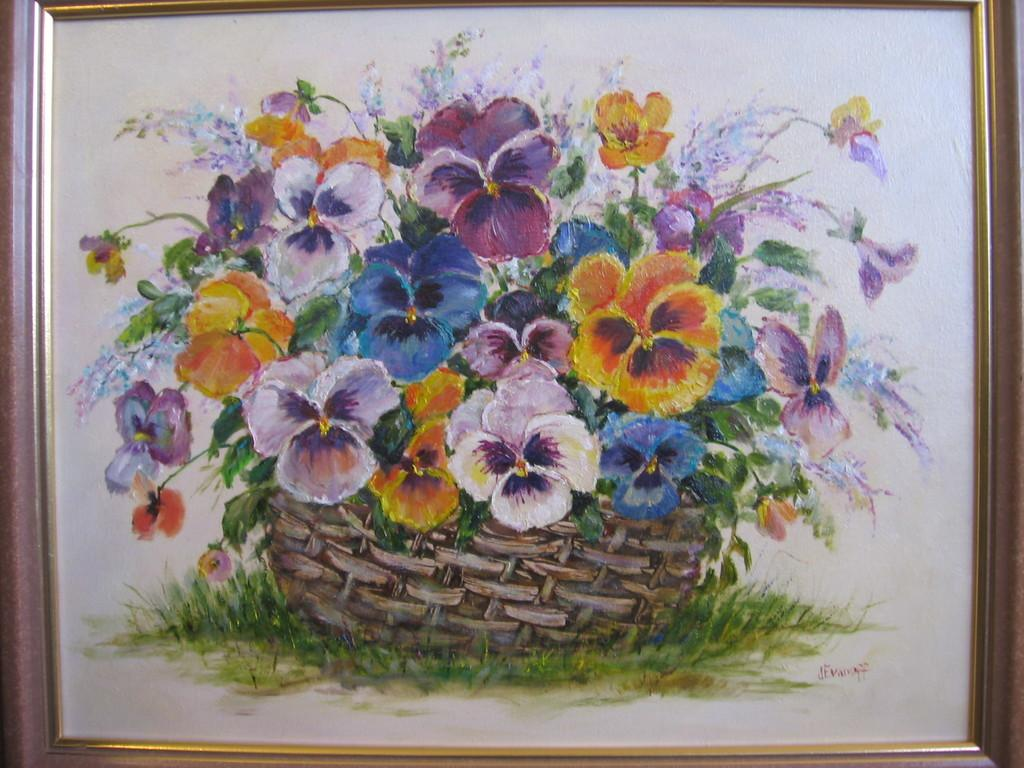What is the main subject of the image? The image contains a frame with a painting. What type of natural elements can be seen in the image? There are flowers and grass in the image. Can you describe any other objects present in the image? Yes, there are other objects in the image. What color is the background of the image? The background of the image is white. What type of fan is visible in the image? There is no fan present in the image. Can you describe the flesh of the person in the painting? There is no person or flesh visible in the image, as it only contains a painting within a frame. 